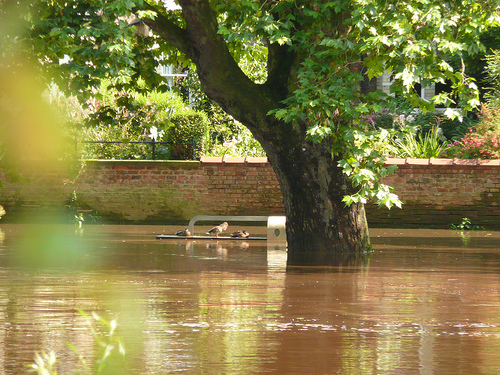<image>
Can you confirm if the water is on the tree? No. The water is not positioned on the tree. They may be near each other, but the water is not supported by or resting on top of the tree. 